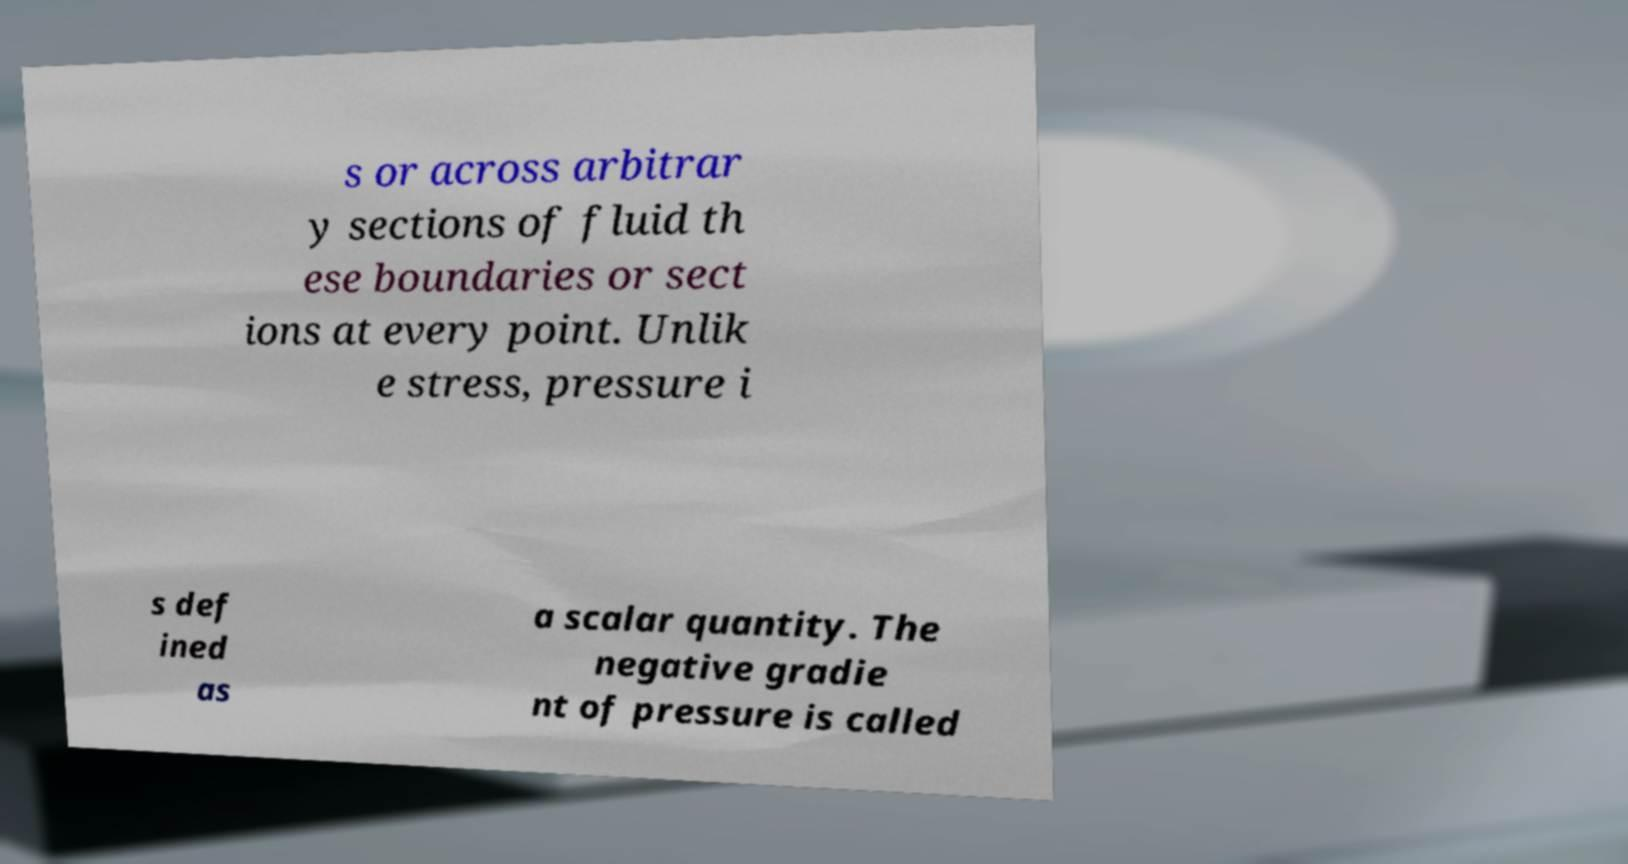Can you accurately transcribe the text from the provided image for me? s or across arbitrar y sections of fluid th ese boundaries or sect ions at every point. Unlik e stress, pressure i s def ined as a scalar quantity. The negative gradie nt of pressure is called 